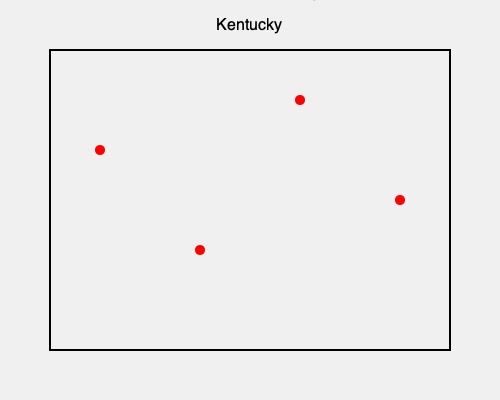Match the following Kentucky landmarks to their approximate locations on the map:

1. Mammoth Cave National Park
2. Churchill Downs
3. Abraham Lincoln Birthplace National Historical Park
4. Cumberland Falls State Resort Park

Which letter corresponds to the location of Churchill Downs? To answer this question, we need to consider the geographical locations of these landmarks within Kentucky:

1. Mammoth Cave National Park is located in central Kentucky, slightly to the southwest. This corresponds to point B on the map.

2. Churchill Downs, home of the Kentucky Derby, is located in Louisville, which is in the north-central part of the state, near the Indiana border. This matches point C on the map.

3. Abraham Lincoln Birthplace National Historical Park is situated in central Kentucky, slightly to the south. This aligns with point A on the map.

4. Cumberland Falls State Resort Park is in the southeastern part of Kentucky, which corresponds to point D on the map.

By process of elimination and geographical knowledge, we can determine that Churchill Downs, being in Louisville in the north-central part of the state, is represented by point C on the map.
Answer: C 